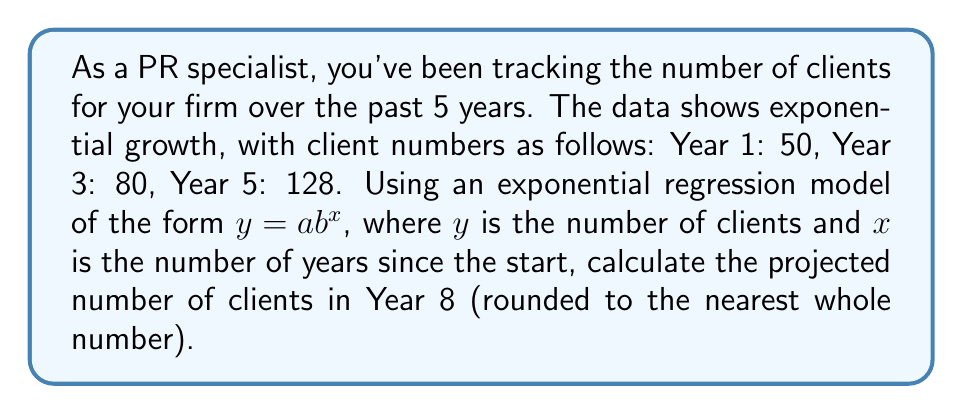Help me with this question. 1. We'll use the exponential regression model $y = ab^x$.

2. We have three data points:
   $(1, 50)$, $(3, 80)$, $(5, 128)$

3. To find $a$ and $b$, we'll use the first and last points:
   $50 = ab^1$ and $128 = ab^5$

4. Divide these equations:
   $\frac{128}{50} = b^4$

5. Solve for $b$:
   $b = \sqrt[4]{\frac{128}{50}} \approx 1.2649$

6. Substitute $b$ back into $50 = ab^1$:
   $50 = a(1.2649)$
   $a = \frac{50}{1.2649} \approx 39.5288$

7. Our model is:
   $y = 39.5288(1.2649)^x$

8. For Year 8, $x = 8$:
   $y = 39.5288(1.2649)^8 \approx 205.0618$

9. Rounding to the nearest whole number: 205
Answer: 205 clients 